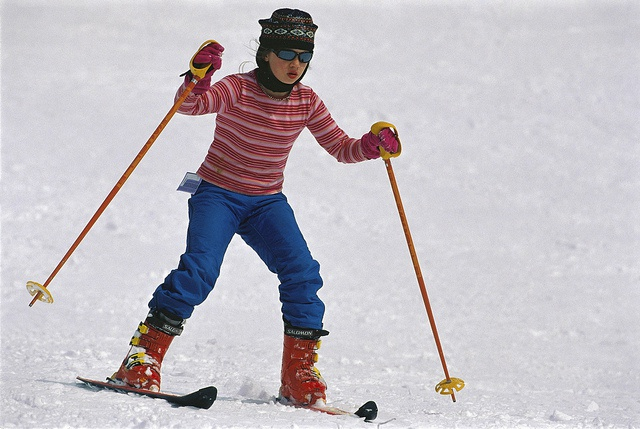Describe the objects in this image and their specific colors. I can see people in lightgray, navy, maroon, black, and brown tones and skis in lightgray, black, darkgray, and gray tones in this image. 